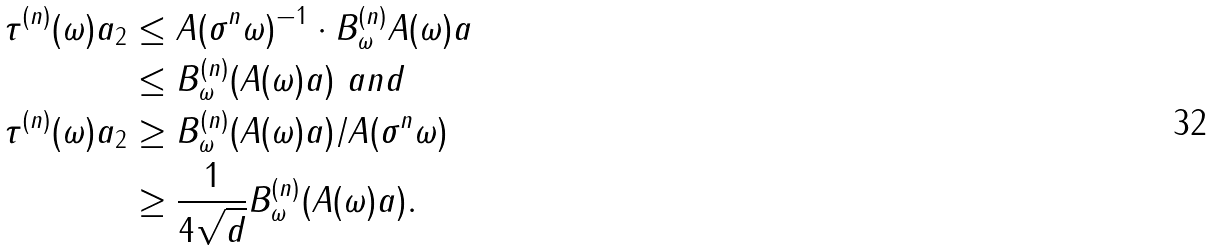<formula> <loc_0><loc_0><loc_500><loc_500>\| \tau ^ { ( n ) } ( \omega ) a \| _ { 2 } & \leq \| A ( \sigma ^ { n } \omega ) ^ { - 1 } \| \cdot \| B ^ { ( n ) } _ { \omega } A ( \omega ) a \| \\ & \leq \| B ^ { ( n ) } _ { \omega } ( A ( \omega ) a ) \| \ a n d \\ \| \tau ^ { ( n ) } ( \omega ) a \| _ { 2 } & \geq \| B ^ { ( n ) } _ { \omega } ( A ( \omega ) a ) \| / \| A ( \sigma ^ { n } \omega ) \| \\ & \geq \frac { 1 } { 4 \sqrt { d } } \| B ^ { ( n ) } _ { \omega } ( A ( \omega ) a ) \| .</formula> 